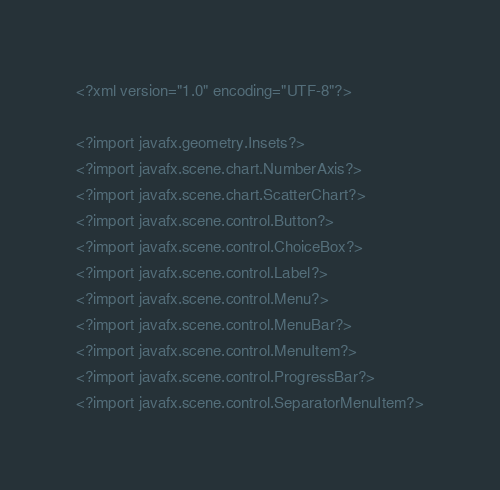<code> <loc_0><loc_0><loc_500><loc_500><_XML_><?xml version="1.0" encoding="UTF-8"?>

<?import javafx.geometry.Insets?>
<?import javafx.scene.chart.NumberAxis?>
<?import javafx.scene.chart.ScatterChart?>
<?import javafx.scene.control.Button?>
<?import javafx.scene.control.ChoiceBox?>
<?import javafx.scene.control.Label?>
<?import javafx.scene.control.Menu?>
<?import javafx.scene.control.MenuBar?>
<?import javafx.scene.control.MenuItem?>
<?import javafx.scene.control.ProgressBar?>
<?import javafx.scene.control.SeparatorMenuItem?></code> 